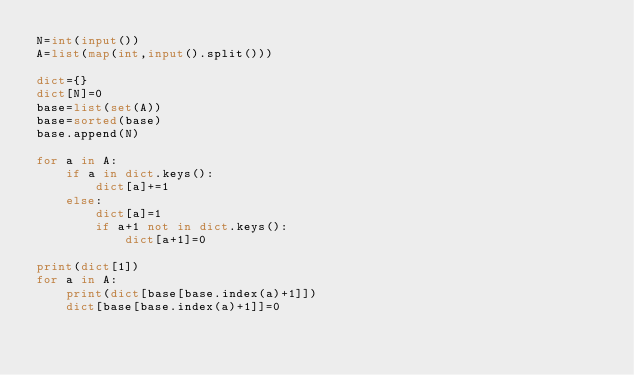Convert code to text. <code><loc_0><loc_0><loc_500><loc_500><_Python_>N=int(input())
A=list(map(int,input().split()))

dict={}
dict[N]=0
base=list(set(A))
base=sorted(base)
base.append(N)

for a in A:
    if a in dict.keys():
        dict[a]+=1
    else:
        dict[a]=1
        if a+1 not in dict.keys():
            dict[a+1]=0

print(dict[1])
for a in A:
    print(dict[base[base.index(a)+1]])
    dict[base[base.index(a)+1]]=0
</code> 